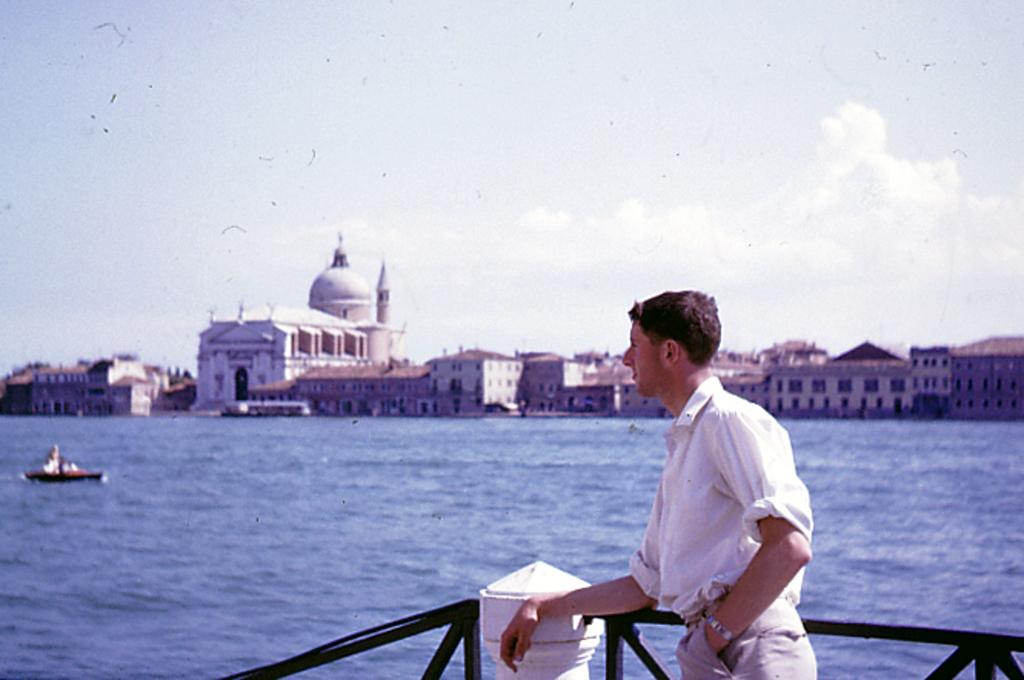What is the man in the image doing? The man is standing at a fence in the image. What can be seen on the water in the image? There is a boat on the water in the image. What type of structures are visible in the background of the image? There are buildings with windows in the background of the image. What is visible in the sky in the image? The sky is visible in the background of the image, and clouds are present. What type of frame is the man using to play the drum in the image? There is no drum or frame present in the image; the man is simply standing at a fence. 